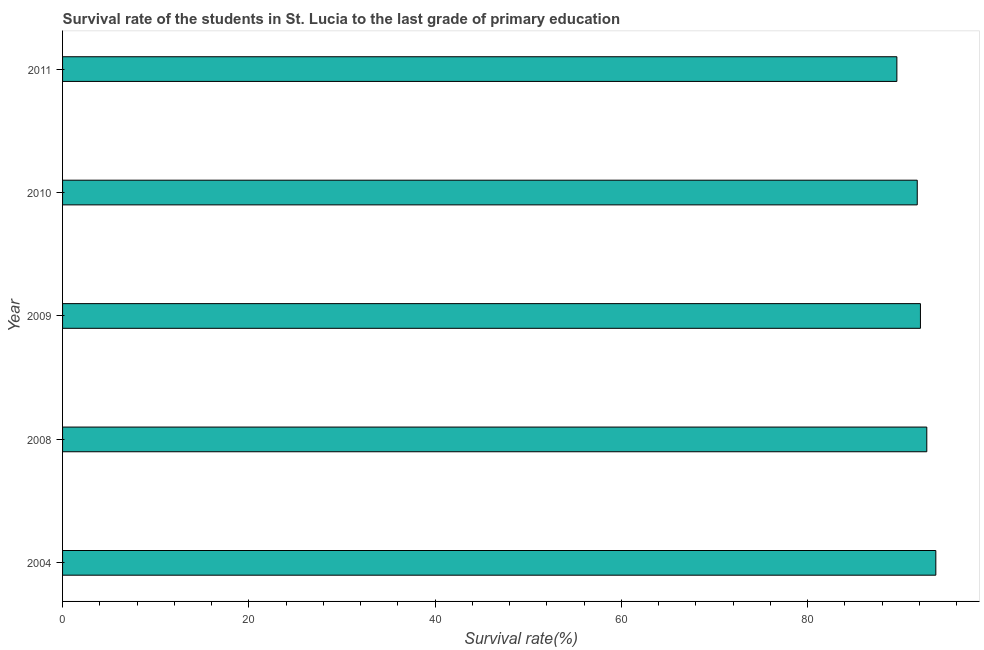Does the graph contain any zero values?
Give a very brief answer. No. What is the title of the graph?
Give a very brief answer. Survival rate of the students in St. Lucia to the last grade of primary education. What is the label or title of the X-axis?
Provide a succinct answer. Survival rate(%). What is the label or title of the Y-axis?
Make the answer very short. Year. What is the survival rate in primary education in 2008?
Ensure brevity in your answer.  92.79. Across all years, what is the maximum survival rate in primary education?
Make the answer very short. 93.76. Across all years, what is the minimum survival rate in primary education?
Offer a very short reply. 89.57. In which year was the survival rate in primary education minimum?
Offer a very short reply. 2011. What is the sum of the survival rate in primary education?
Provide a succinct answer. 459.98. What is the difference between the survival rate in primary education in 2008 and 2010?
Provide a succinct answer. 1.02. What is the average survival rate in primary education per year?
Your answer should be compact. 92. What is the median survival rate in primary education?
Your answer should be compact. 92.1. Do a majority of the years between 2009 and 2004 (inclusive) have survival rate in primary education greater than 88 %?
Your answer should be compact. Yes. What is the ratio of the survival rate in primary education in 2009 to that in 2011?
Keep it short and to the point. 1.03. What is the difference between the highest and the lowest survival rate in primary education?
Ensure brevity in your answer.  4.18. In how many years, is the survival rate in primary education greater than the average survival rate in primary education taken over all years?
Provide a succinct answer. 3. Are all the bars in the graph horizontal?
Make the answer very short. Yes. What is the Survival rate(%) in 2004?
Your answer should be very brief. 93.76. What is the Survival rate(%) of 2008?
Provide a short and direct response. 92.79. What is the Survival rate(%) of 2009?
Provide a succinct answer. 92.1. What is the Survival rate(%) of 2010?
Make the answer very short. 91.76. What is the Survival rate(%) in 2011?
Give a very brief answer. 89.57. What is the difference between the Survival rate(%) in 2004 and 2008?
Provide a succinct answer. 0.97. What is the difference between the Survival rate(%) in 2004 and 2009?
Provide a succinct answer. 1.65. What is the difference between the Survival rate(%) in 2004 and 2010?
Keep it short and to the point. 1.99. What is the difference between the Survival rate(%) in 2004 and 2011?
Offer a terse response. 4.18. What is the difference between the Survival rate(%) in 2008 and 2009?
Offer a very short reply. 0.68. What is the difference between the Survival rate(%) in 2008 and 2010?
Provide a succinct answer. 1.03. What is the difference between the Survival rate(%) in 2008 and 2011?
Keep it short and to the point. 3.21. What is the difference between the Survival rate(%) in 2009 and 2010?
Make the answer very short. 0.34. What is the difference between the Survival rate(%) in 2009 and 2011?
Offer a terse response. 2.53. What is the difference between the Survival rate(%) in 2010 and 2011?
Provide a short and direct response. 2.19. What is the ratio of the Survival rate(%) in 2004 to that in 2008?
Provide a succinct answer. 1.01. What is the ratio of the Survival rate(%) in 2004 to that in 2009?
Keep it short and to the point. 1.02. What is the ratio of the Survival rate(%) in 2004 to that in 2011?
Make the answer very short. 1.05. What is the ratio of the Survival rate(%) in 2008 to that in 2009?
Your answer should be very brief. 1.01. What is the ratio of the Survival rate(%) in 2008 to that in 2010?
Offer a very short reply. 1.01. What is the ratio of the Survival rate(%) in 2008 to that in 2011?
Your response must be concise. 1.04. What is the ratio of the Survival rate(%) in 2009 to that in 2010?
Give a very brief answer. 1. What is the ratio of the Survival rate(%) in 2009 to that in 2011?
Provide a short and direct response. 1.03. 